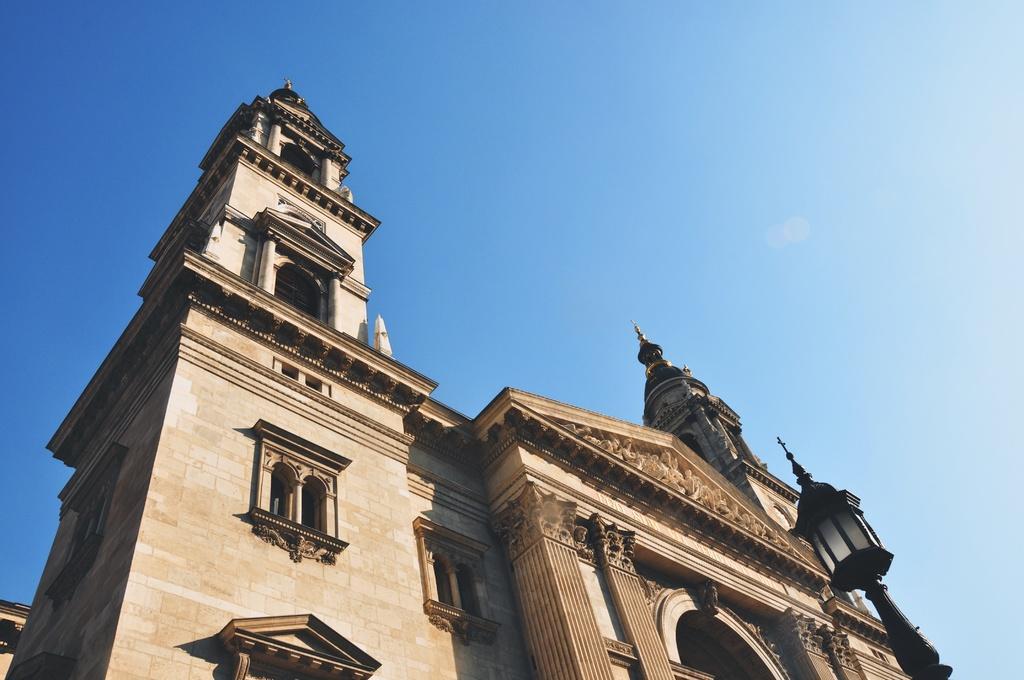Describe this image in one or two sentences. In the image there is a beautiful architecture with perfect carvings and designs, the picture is captured from the downside of the architecture. 